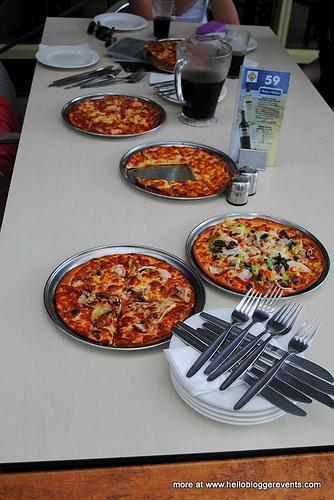How many pizzas have been half-eaten?
Give a very brief answer. 1. 